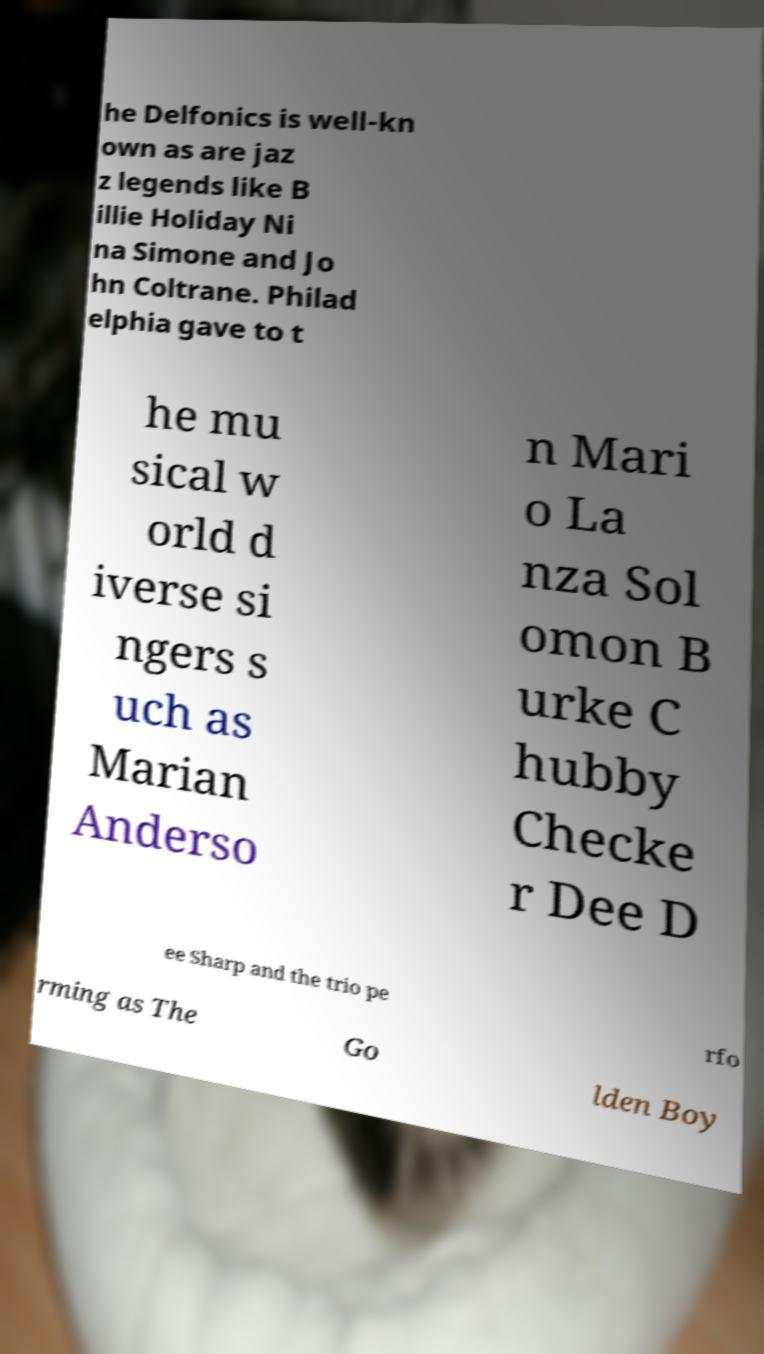For documentation purposes, I need the text within this image transcribed. Could you provide that? he Delfonics is well-kn own as are jaz z legends like B illie Holiday Ni na Simone and Jo hn Coltrane. Philad elphia gave to t he mu sical w orld d iverse si ngers s uch as Marian Anderso n Mari o La nza Sol omon B urke C hubby Checke r Dee D ee Sharp and the trio pe rfo rming as The Go lden Boy 